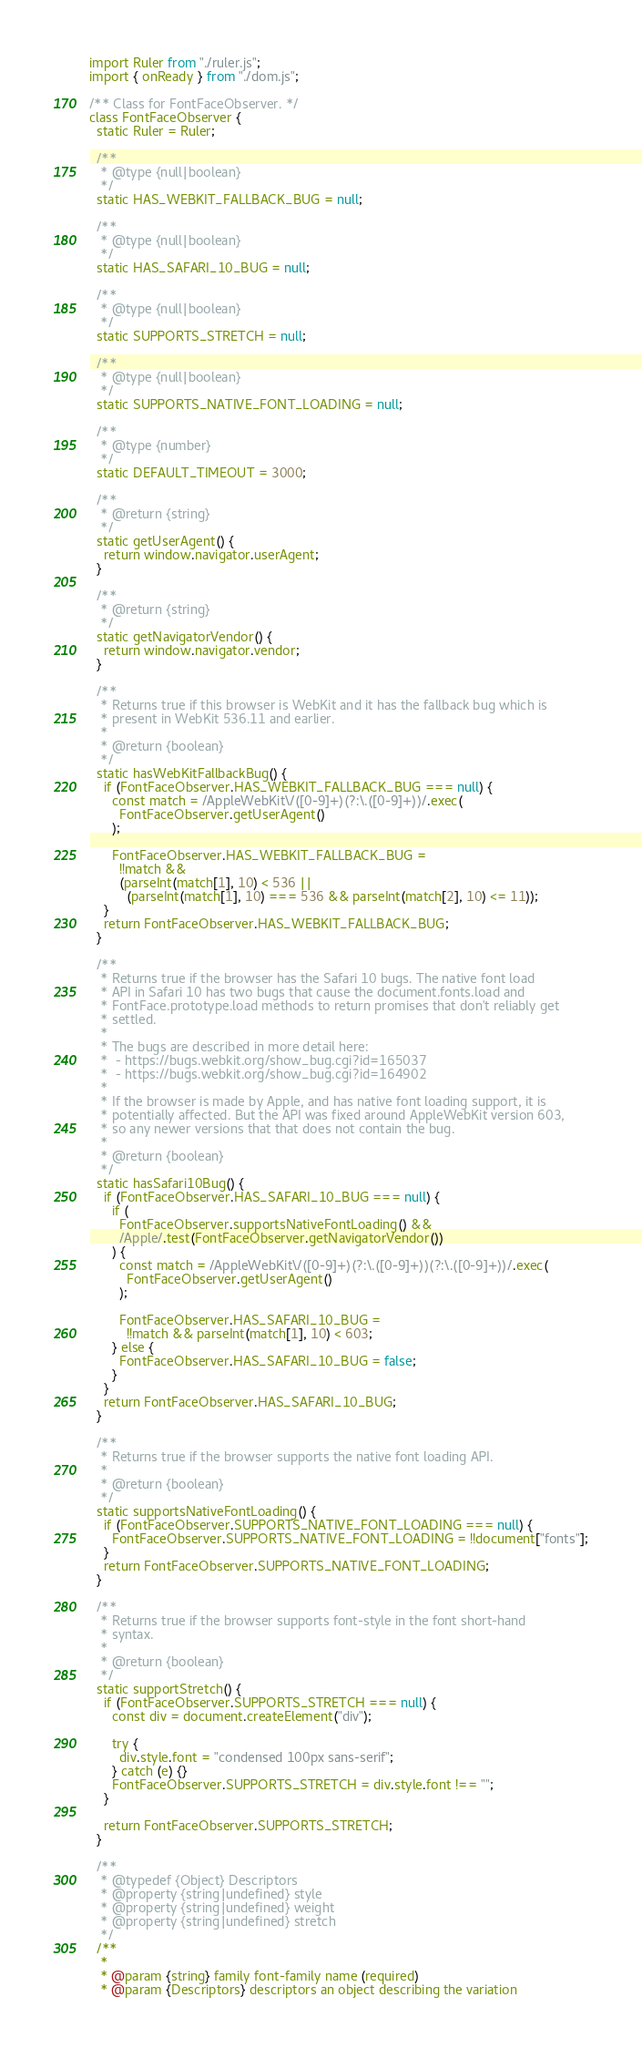Convert code to text. <code><loc_0><loc_0><loc_500><loc_500><_JavaScript_>import Ruler from "./ruler.js";
import { onReady } from "./dom.js";

/** Class for FontFaceObserver. */
class FontFaceObserver {
  static Ruler = Ruler;

  /**
   * @type {null|boolean}
   */
  static HAS_WEBKIT_FALLBACK_BUG = null;

  /**
   * @type {null|boolean}
   */
  static HAS_SAFARI_10_BUG = null;

  /**
   * @type {null|boolean}
   */
  static SUPPORTS_STRETCH = null;

  /**
   * @type {null|boolean}
   */
  static SUPPORTS_NATIVE_FONT_LOADING = null;

  /**
   * @type {number}
   */
  static DEFAULT_TIMEOUT = 3000;

  /**
   * @return {string}
   */
  static getUserAgent() {
    return window.navigator.userAgent;
  }

  /**
   * @return {string}
   */
  static getNavigatorVendor() {
    return window.navigator.vendor;
  }

  /**
   * Returns true if this browser is WebKit and it has the fallback bug which is
   * present in WebKit 536.11 and earlier.
   *
   * @return {boolean}
   */
  static hasWebKitFallbackBug() {
    if (FontFaceObserver.HAS_WEBKIT_FALLBACK_BUG === null) {
      const match = /AppleWebKit\/([0-9]+)(?:\.([0-9]+))/.exec(
        FontFaceObserver.getUserAgent()
      );

      FontFaceObserver.HAS_WEBKIT_FALLBACK_BUG =
        !!match &&
        (parseInt(match[1], 10) < 536 ||
          (parseInt(match[1], 10) === 536 && parseInt(match[2], 10) <= 11));
    }
    return FontFaceObserver.HAS_WEBKIT_FALLBACK_BUG;
  }

  /**
   * Returns true if the browser has the Safari 10 bugs. The native font load
   * API in Safari 10 has two bugs that cause the document.fonts.load and
   * FontFace.prototype.load methods to return promises that don't reliably get
   * settled.
   *
   * The bugs are described in more detail here:
   *  - https://bugs.webkit.org/show_bug.cgi?id=165037
   *  - https://bugs.webkit.org/show_bug.cgi?id=164902
   *
   * If the browser is made by Apple, and has native font loading support, it is
   * potentially affected. But the API was fixed around AppleWebKit version 603,
   * so any newer versions that that does not contain the bug.
   *
   * @return {boolean}
   */
  static hasSafari10Bug() {
    if (FontFaceObserver.HAS_SAFARI_10_BUG === null) {
      if (
        FontFaceObserver.supportsNativeFontLoading() &&
        /Apple/.test(FontFaceObserver.getNavigatorVendor())
      ) {
        const match = /AppleWebKit\/([0-9]+)(?:\.([0-9]+))(?:\.([0-9]+))/.exec(
          FontFaceObserver.getUserAgent()
        );

        FontFaceObserver.HAS_SAFARI_10_BUG =
          !!match && parseInt(match[1], 10) < 603;
      } else {
        FontFaceObserver.HAS_SAFARI_10_BUG = false;
      }
    }
    return FontFaceObserver.HAS_SAFARI_10_BUG;
  }

  /**
   * Returns true if the browser supports the native font loading API.
   *
   * @return {boolean}
   */
  static supportsNativeFontLoading() {
    if (FontFaceObserver.SUPPORTS_NATIVE_FONT_LOADING === null) {
      FontFaceObserver.SUPPORTS_NATIVE_FONT_LOADING = !!document["fonts"];
    }
    return FontFaceObserver.SUPPORTS_NATIVE_FONT_LOADING;
  }

  /**
   * Returns true if the browser supports font-style in the font short-hand
   * syntax.
   *
   * @return {boolean}
   */
  static supportStretch() {
    if (FontFaceObserver.SUPPORTS_STRETCH === null) {
      const div = document.createElement("div");

      try {
        div.style.font = "condensed 100px sans-serif";
      } catch (e) {}
      FontFaceObserver.SUPPORTS_STRETCH = div.style.font !== "";
    }

    return FontFaceObserver.SUPPORTS_STRETCH;
  }

  /**
   * @typedef {Object} Descriptors
   * @property {string|undefined} style
   * @property {string|undefined} weight
   * @property {string|undefined} stretch
   */
  /**
   *
   * @param {string} family font-family name (required)
   * @param {Descriptors} descriptors an object describing the variation</code> 